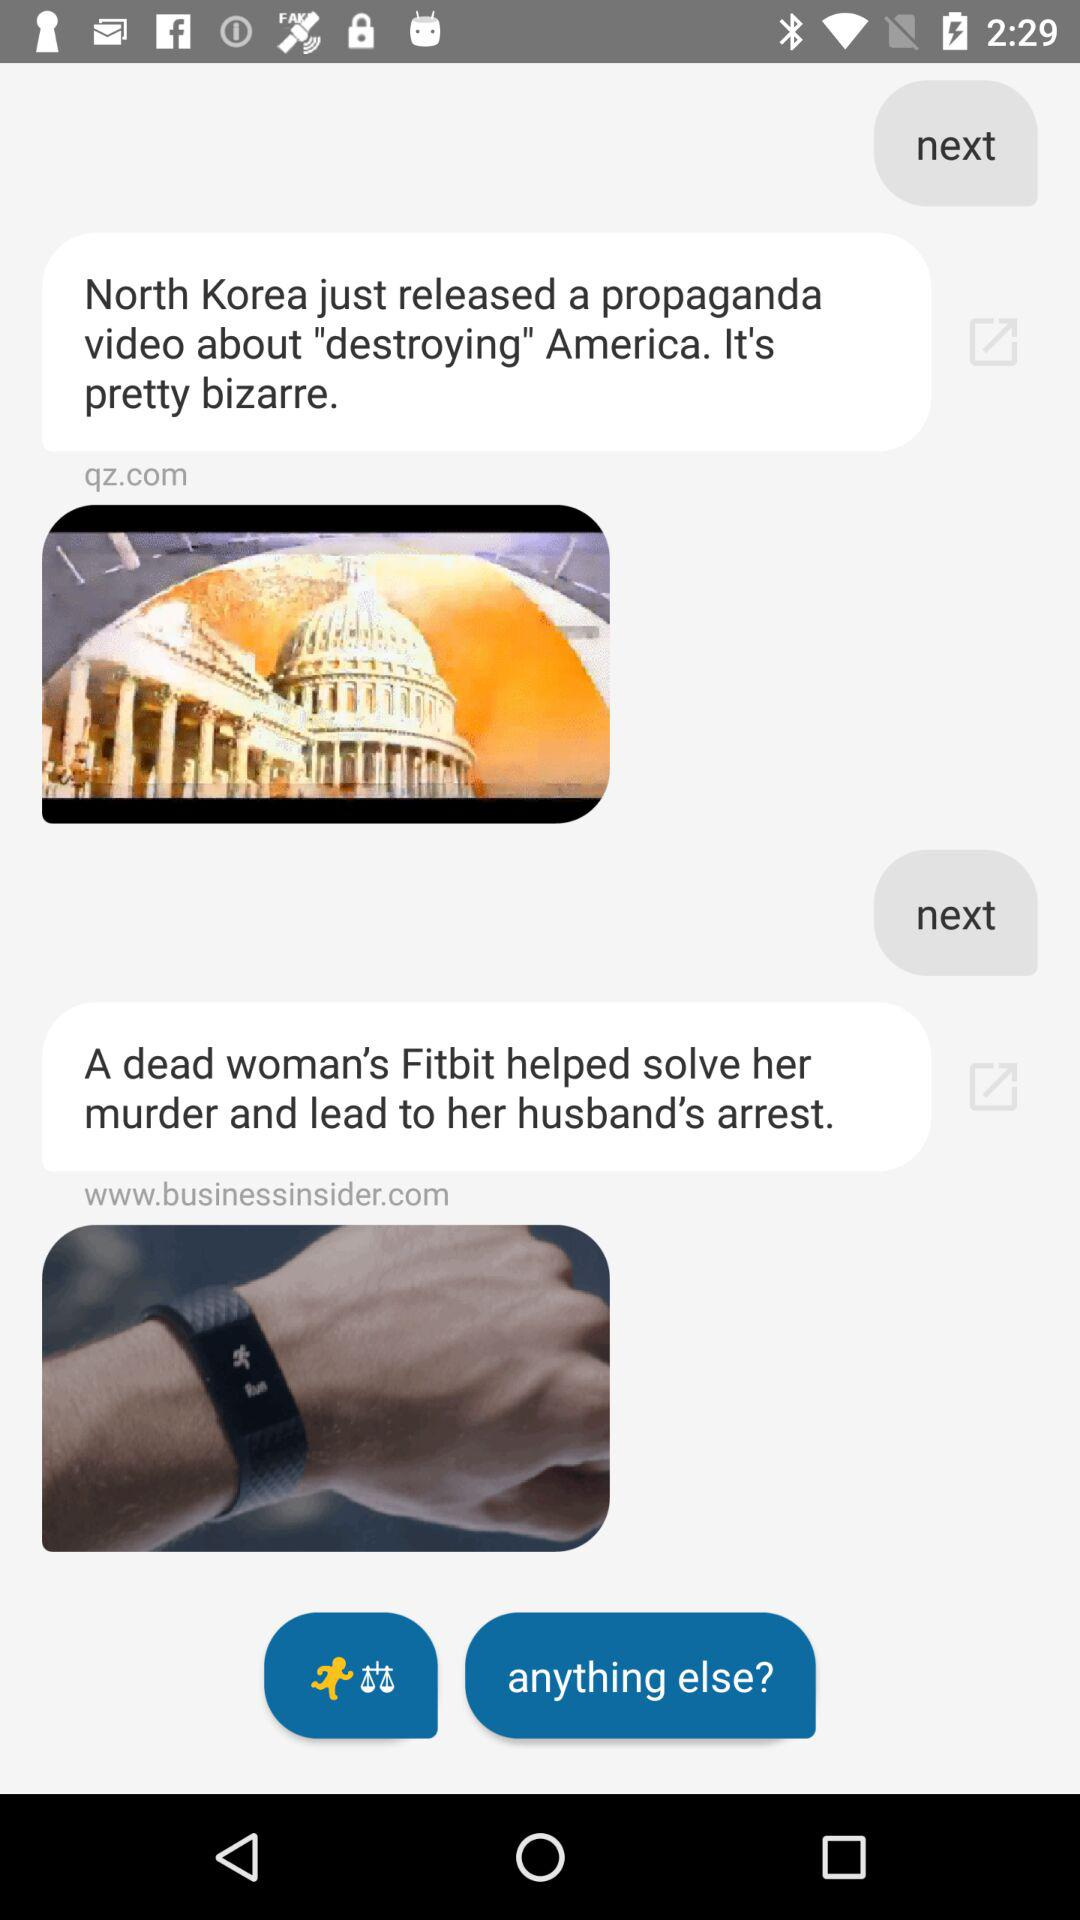From which website has the news about a dead woman been shared? The website from which the news about a dead woman has been shared is www.businessinsider.com. 